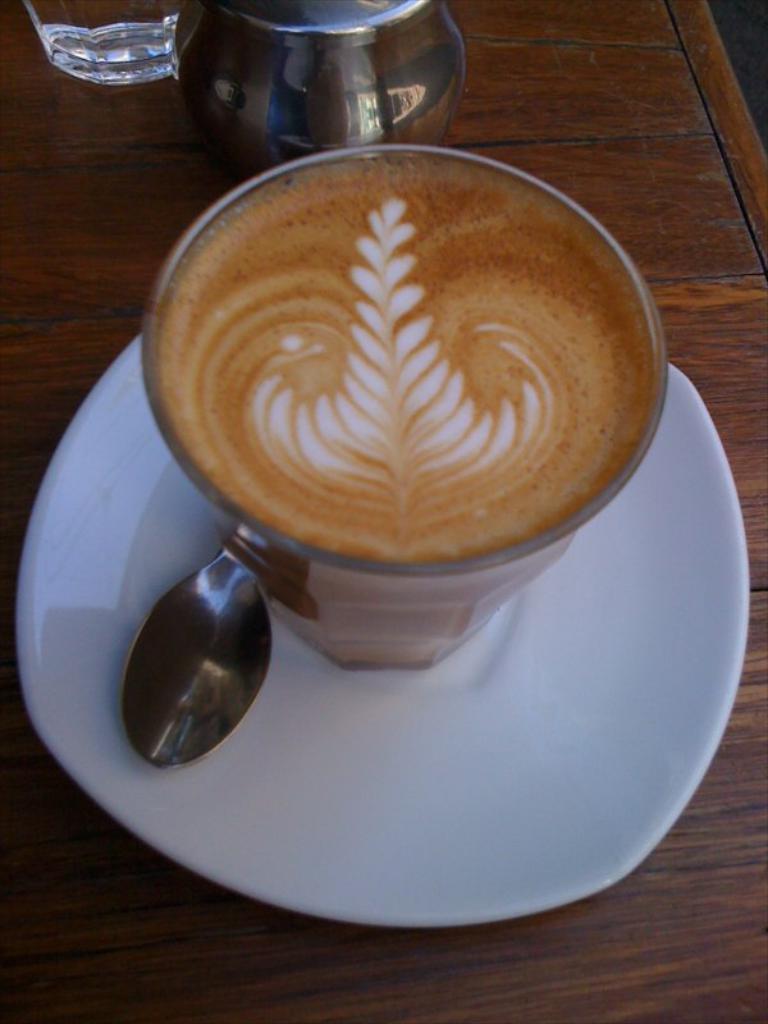How would you summarize this image in a sentence or two? In this picture we can see a cup and a spoon in the saucer, beside to the cup we can find a glass and a jug on the table. 